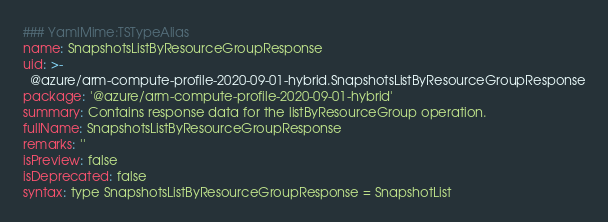Convert code to text. <code><loc_0><loc_0><loc_500><loc_500><_YAML_>### YamlMime:TSTypeAlias
name: SnapshotsListByResourceGroupResponse
uid: >-
  @azure/arm-compute-profile-2020-09-01-hybrid.SnapshotsListByResourceGroupResponse
package: '@azure/arm-compute-profile-2020-09-01-hybrid'
summary: Contains response data for the listByResourceGroup operation.
fullName: SnapshotsListByResourceGroupResponse
remarks: ''
isPreview: false
isDeprecated: false
syntax: type SnapshotsListByResourceGroupResponse = SnapshotList
</code> 